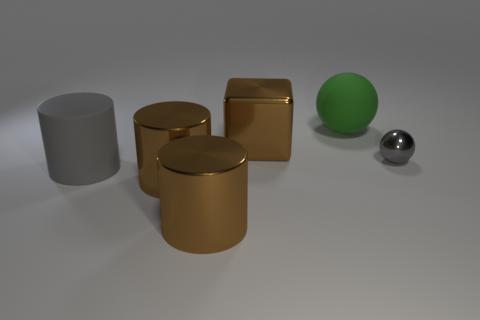What is the color of the ball that is the same size as the cube?
Offer a terse response. Green. Is there a brown shiny block?
Your answer should be compact. Yes. The big thing right of the large brown metallic block has what shape?
Provide a short and direct response. Sphere. What number of balls are both to the right of the green rubber thing and behind the small thing?
Offer a terse response. 0. Is there a gray cylinder that has the same material as the big gray object?
Your answer should be compact. No. What size is the metal object that is the same color as the large matte cylinder?
Offer a very short reply. Small. What number of spheres are big green matte objects or small gray metallic things?
Your response must be concise. 2. How big is the gray cylinder?
Your answer should be compact. Large. How many big matte things are in front of the green thing?
Offer a very short reply. 1. What size is the rubber thing behind the gray thing that is in front of the gray shiny sphere?
Ensure brevity in your answer.  Large. 